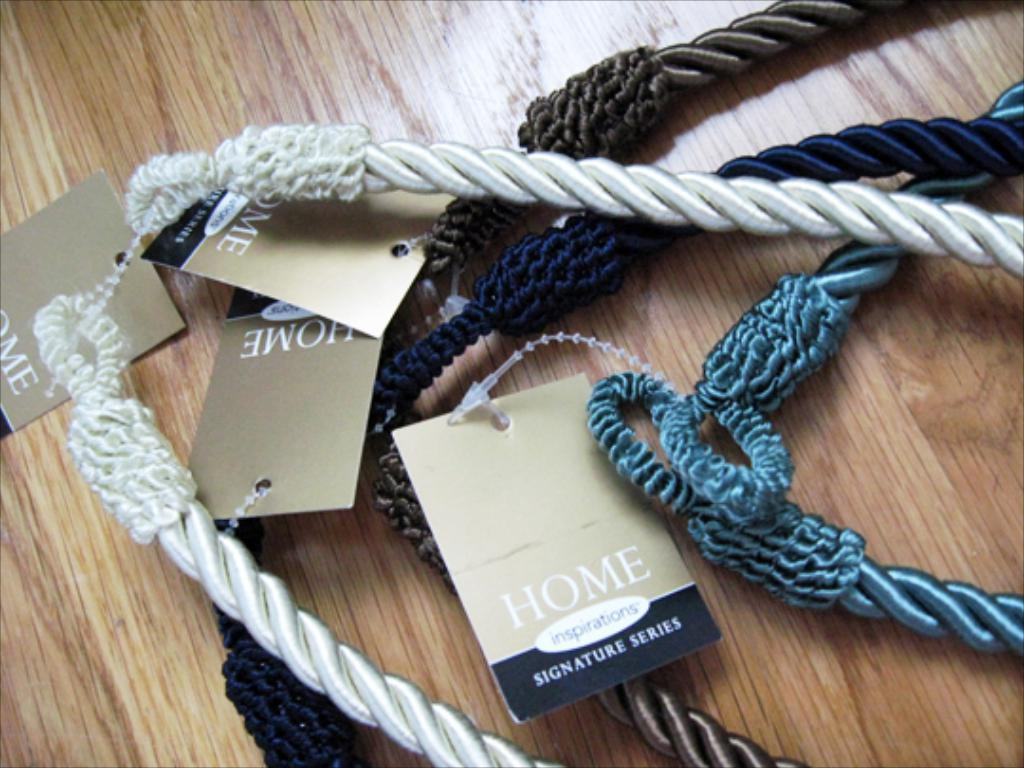What type of objects can be seen in the image? There are ropes of different colors in the image. Are there any additional features on the ropes? Yes, the ropes have tags attached to them. What is the ropes placed on in the image? The ropes are placed on a wooden platform. How many yams are being weighed on the calculator in the image? There are no yams or calculators present in the image; it features ropes with tags on a wooden platform. 